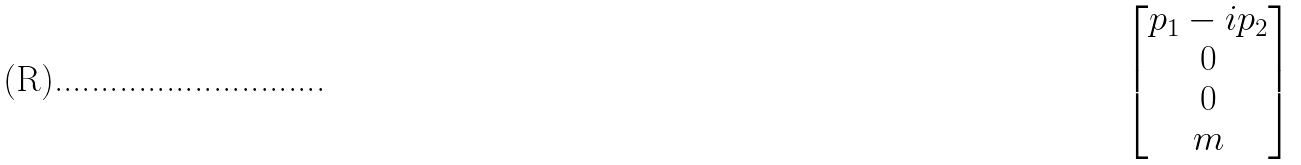<formula> <loc_0><loc_0><loc_500><loc_500>\begin{bmatrix} p _ { 1 } - i p _ { 2 } \\ 0 \\ 0 \\ m \end{bmatrix}</formula> 